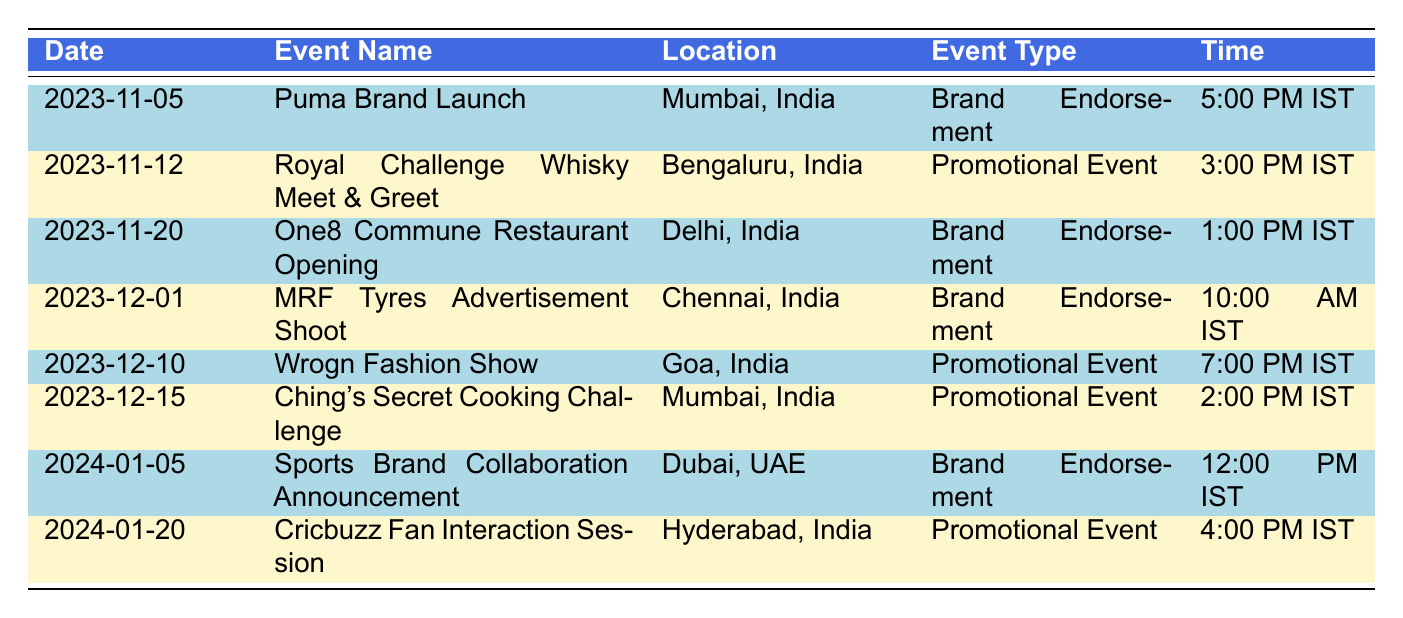What is the next event scheduled for Virat Kohli? The next event date is November 5, 2023, for the Puma Brand Launch.
Answer: Puma Brand Launch What type of event is the One8 Commune Restaurant Opening? The table indicates that the One8 Commune Restaurant Opening on November 20, 2023, is a Brand Endorsement event.
Answer: Brand Endorsement How many promotional events are there in the schedule? By counting the promotional events listed (Royal Challenge Whisky Meet & Greet, Wrogn Fashion Show, Ching's Secret Cooking Challenge, and Cricbuzz Fan Interaction Session), there are 4 promotional events in total.
Answer: 4 Is the Sports Brand Collaboration Announcement taking place in India? The Sports Brand Collaboration Announcement is scheduled for January 5, 2024, and the location is Dubai, UAE, so it is not taking place in India.
Answer: No What time is the Puma Brand Launch event scheduled? The Puma Brand Launch event on November 5, 2023, is scheduled for 5:00 PM IST.
Answer: 5:00 PM IST Which event takes place last in the year 2023? The last event of 2023 is the Ching's Secret Cooking Challenge on December 15, 2023, which is the latest date listed for that year.
Answer: Ching's Secret Cooking Challenge If you attend the Royal Challenge Whisky Meet & Greet, what will be the duration of the event from the start of the day? The event starts at 3:00 PM IST on November 12, 2023, which means it starts 15 hours into the day.
Answer: 15 hours Which city hosts the most events according to the schedule? Mumbai hosts two events (Puma Brand Launch and Ching's Secret Cooking Challenge), making it the city with the most events in the schedule.
Answer: Mumbai When is the next brand endorsement event after the One8 Commune Restaurant Opening? The next brand endorsement event after the One8 Commune Restaurant Opening on November 20, 2023, is the Sports Brand Collaboration Announcement on January 5, 2024.
Answer: Sports Brand Collaboration Announcement 